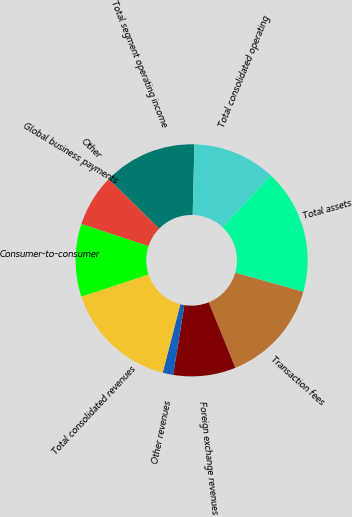Convert chart. <chart><loc_0><loc_0><loc_500><loc_500><pie_chart><fcel>Transaction fees<fcel>Foreign exchange revenues<fcel>Other revenues<fcel>Total consolidated revenues<fcel>Consumer-to-consumer<fcel>Global business payments<fcel>Other<fcel>Total segment operating income<fcel>Total consolidated operating<fcel>Total assets<nl><fcel>14.49%<fcel>8.7%<fcel>1.46%<fcel>15.93%<fcel>10.14%<fcel>7.25%<fcel>0.01%<fcel>13.04%<fcel>11.59%<fcel>17.38%<nl></chart> 